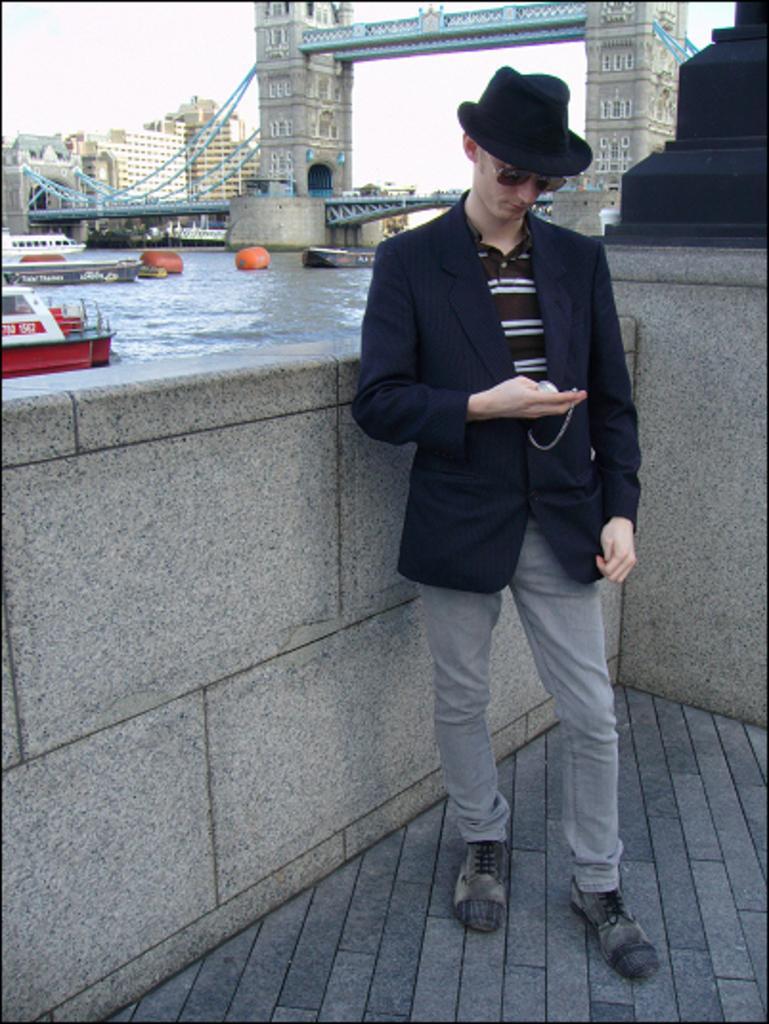How would you summarize this image in a sentence or two? In this picture we can see a person holding an object. A compound wall is visible from left to right. Some boats are visible in the water. There is a bridge. We can see a few buildings in the background. 